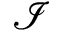<formula> <loc_0><loc_0><loc_500><loc_500>\mathcal { I }</formula> 